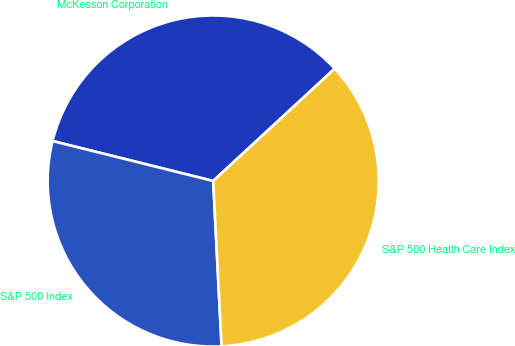<chart> <loc_0><loc_0><loc_500><loc_500><pie_chart><fcel>McKesson Corporation<fcel>S&P 500 Index<fcel>S&P 500 Health Care Index<nl><fcel>34.25%<fcel>29.69%<fcel>36.07%<nl></chart> 